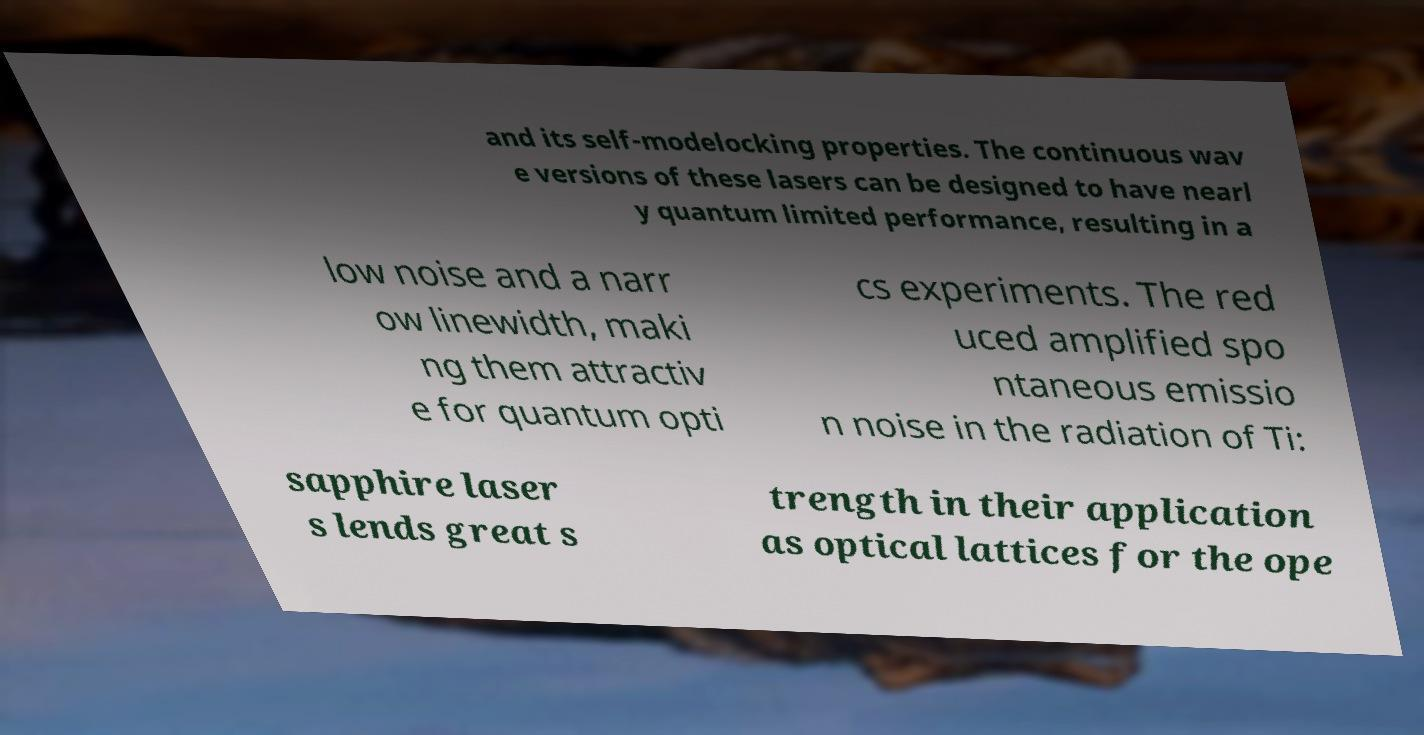There's text embedded in this image that I need extracted. Can you transcribe it verbatim? and its self-modelocking properties. The continuous wav e versions of these lasers can be designed to have nearl y quantum limited performance, resulting in a low noise and a narr ow linewidth, maki ng them attractiv e for quantum opti cs experiments. The red uced amplified spo ntaneous emissio n noise in the radiation of Ti: sapphire laser s lends great s trength in their application as optical lattices for the ope 